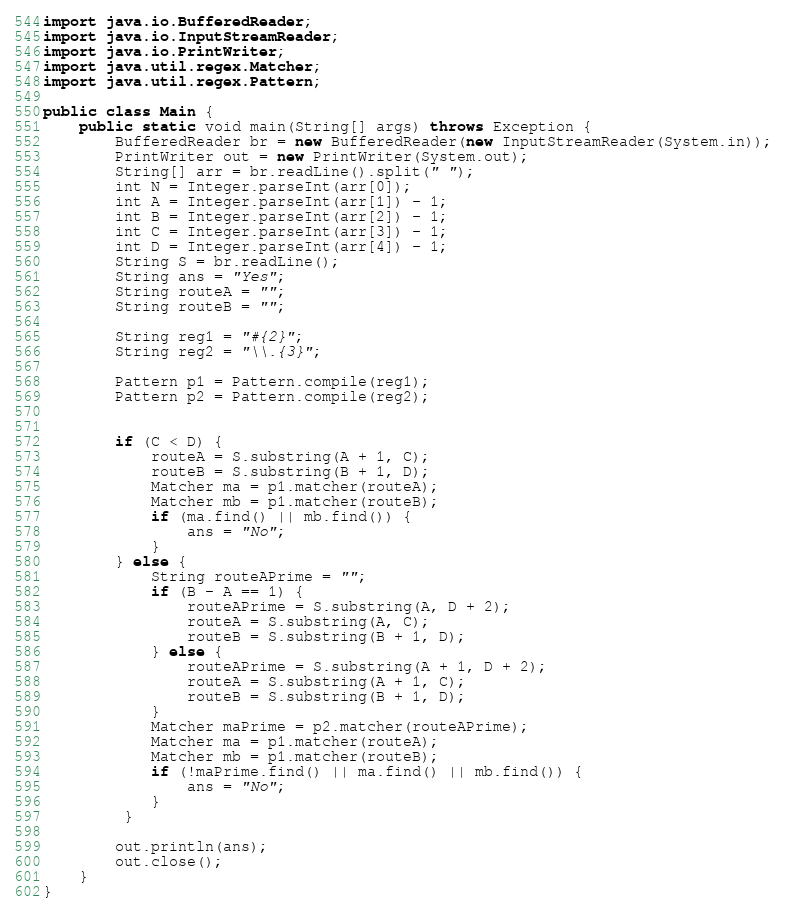<code> <loc_0><loc_0><loc_500><loc_500><_Java_>import java.io.BufferedReader;
import java.io.InputStreamReader;
import java.io.PrintWriter;
import java.util.regex.Matcher;
import java.util.regex.Pattern;

public class Main {
    public static void main(String[] args) throws Exception {
        BufferedReader br = new BufferedReader(new InputStreamReader(System.in));
        PrintWriter out = new PrintWriter(System.out);
        String[] arr = br.readLine().split(" ");
        int N = Integer.parseInt(arr[0]);
        int A = Integer.parseInt(arr[1]) - 1;
        int B = Integer.parseInt(arr[2]) - 1;
        int C = Integer.parseInt(arr[3]) - 1;
        int D = Integer.parseInt(arr[4]) - 1;
        String S = br.readLine();
        String ans = "Yes";
        String routeA = "";
        String routeB = "";

        String reg1 = "#{2}";
        String reg2 = "\\.{3}";

        Pattern p1 = Pattern.compile(reg1);
        Pattern p2 = Pattern.compile(reg2);


        if (C < D) {
            routeA = S.substring(A + 1, C);
            routeB = S.substring(B + 1, D);
            Matcher ma = p1.matcher(routeA);
            Matcher mb = p1.matcher(routeB);
            if (ma.find() || mb.find()) {
                ans = "No";
            } 
        } else {
            String routeAPrime = "";
            if (B - A == 1) {
                routeAPrime = S.substring(A, D + 2);
                routeA = S.substring(A, C);
                routeB = S.substring(B + 1, D);
            } else {
                routeAPrime = S.substring(A + 1, D + 2);
                routeA = S.substring(A + 1, C);
                routeB = S.substring(B + 1, D);
            }
            Matcher maPrime = p2.matcher(routeAPrime);
            Matcher ma = p1.matcher(routeA);
            Matcher mb = p1.matcher(routeB);
            if (!maPrime.find() || ma.find() || mb.find()) {
                ans = "No";
            } 
         }

        out.println(ans);
        out.close();
    }
}
</code> 